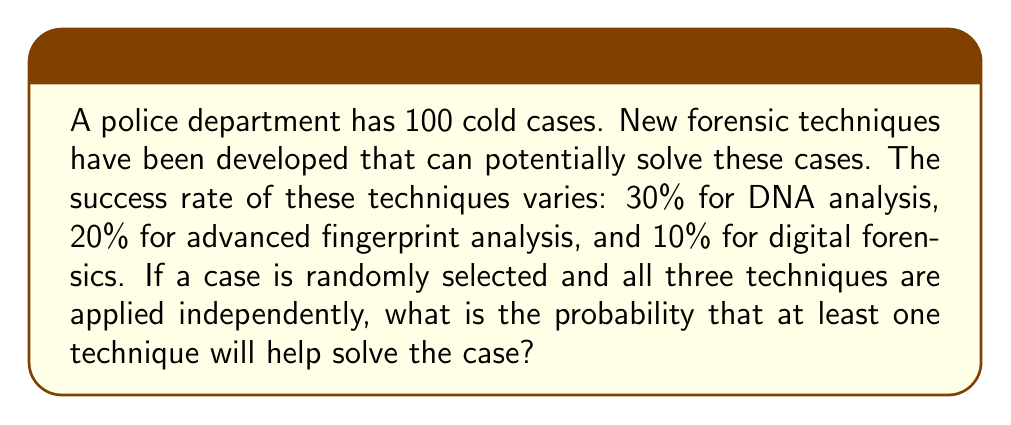Help me with this question. Let's approach this step-by-step:

1) First, we need to calculate the probability that none of the techniques will solve the case. We can then subtract this from 1 to get the probability that at least one technique will solve the case.

2) The probability of DNA analysis not solving the case is:
   $1 - 0.30 = 0.70$

3) The probability of advanced fingerprint analysis not solving the case is:
   $1 - 0.20 = 0.80$

4) The probability of digital forensics not solving the case is:
   $1 - 0.10 = 0.90$

5) Since the techniques are applied independently, we can multiply these probabilities:
   $P(\text{no technique solves}) = 0.70 \times 0.80 \times 0.90 = 0.504$

6) Therefore, the probability that at least one technique will solve the case is:
   $P(\text{at least one solves}) = 1 - P(\text{no technique solves})$
   $= 1 - 0.504 = 0.496$

7) Converting to a percentage:
   $0.496 \times 100\% = 49.6\%$
Answer: 49.6% 